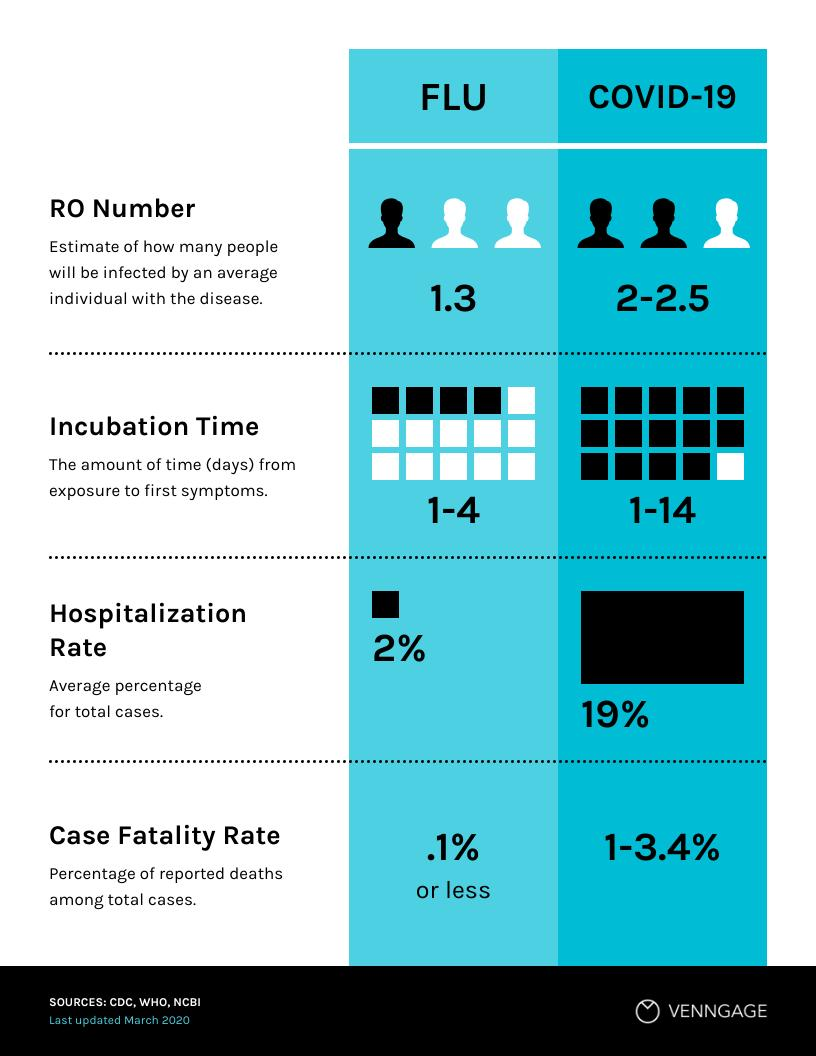Give some essential details in this illustration. The hospitalization rate of COVID-19 is higher by 17% compared to the flu. COVID-19 has a higher RON number than flu. Under the incubation period of COVID-19, how many squares are black in color? 14... 